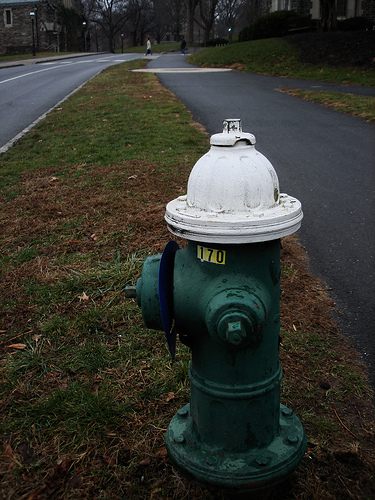Please provide a short description for this region: [0.5, 0.49, 0.59, 0.53]. This area corresponds to the numbers on the water hydrant, specifically reading '170'. These numerals likely indicate operation-related information or a reference for municipal services. 